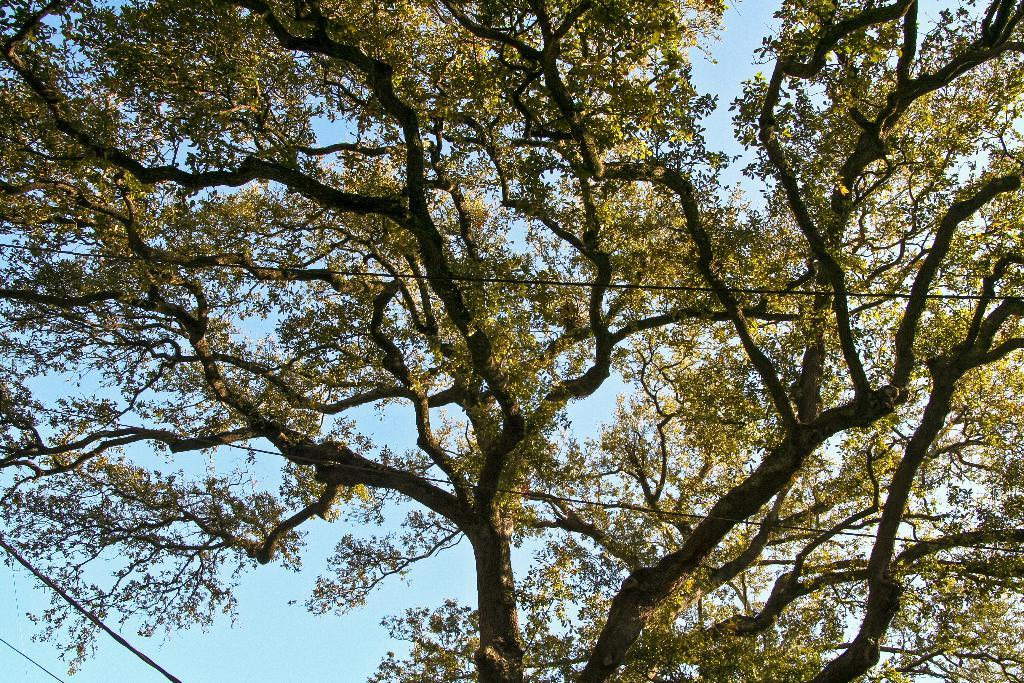What type of vegetation can be seen in the image? There are trees in the image. What else is present in the image besides trees? There are wires in the image. What can be seen in the background of the image? The sky is visible in the background of the image. Can you see a baby playing with a toad near the trees in the image? There is no baby or toad present in the image; it only features trees and wires. 